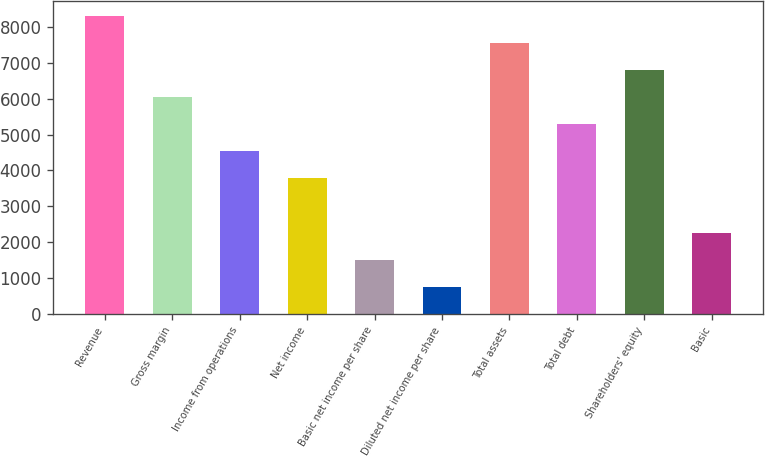Convert chart. <chart><loc_0><loc_0><loc_500><loc_500><bar_chart><fcel>Revenue<fcel>Gross margin<fcel>Income from operations<fcel>Net income<fcel>Basic net income per share<fcel>Diluted net income per share<fcel>Total assets<fcel>Total debt<fcel>Shareholders' equity<fcel>Basic<nl><fcel>8308.23<fcel>6042.42<fcel>4531.88<fcel>3776.61<fcel>1510.8<fcel>755.53<fcel>7552.96<fcel>5287.15<fcel>6797.69<fcel>2266.07<nl></chart> 